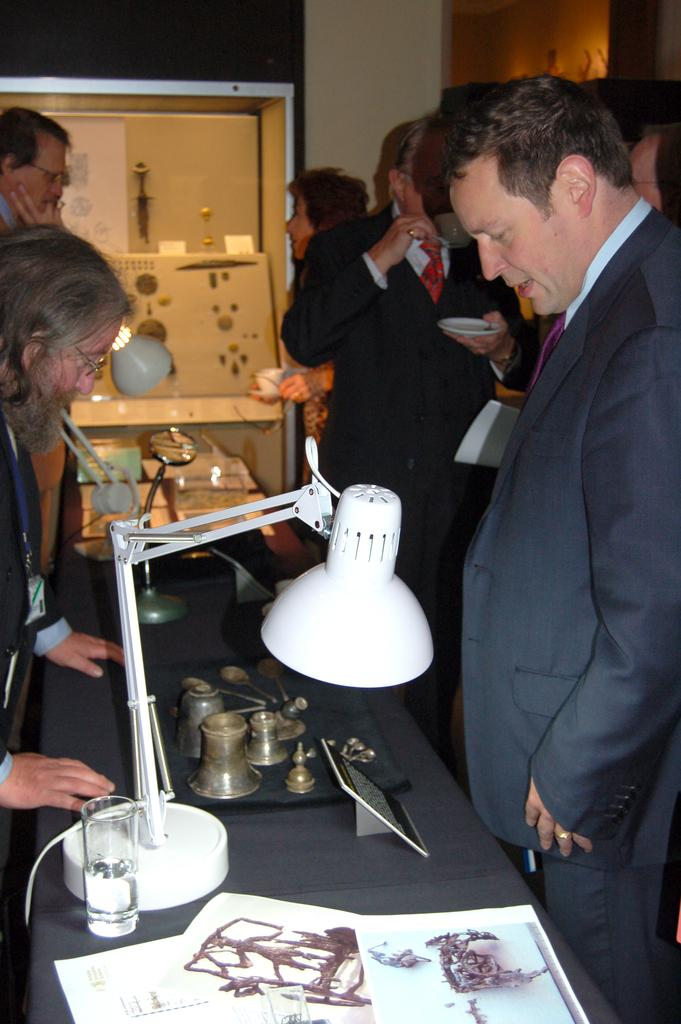What is happening in the image involving people? There are people standing in the image. Can you describe the man in the image? There is a man in the image, and he is watching items on a table. What is the main object in the image that the man is focusing on? The main object in the image that the man is focusing on is a table. What is the man reading on the table in the image? There is no indication in the image that the man is reading anything; he is simply watching items on the table. 